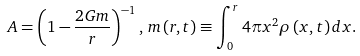Convert formula to latex. <formula><loc_0><loc_0><loc_500><loc_500>A = \left ( 1 - \frac { 2 G m } { r } \right ) ^ { - 1 } , \, m \left ( r , t \right ) \equiv \int _ { 0 } ^ { r } 4 \pi x ^ { 2 } \rho \left ( x , t \right ) d x .</formula> 